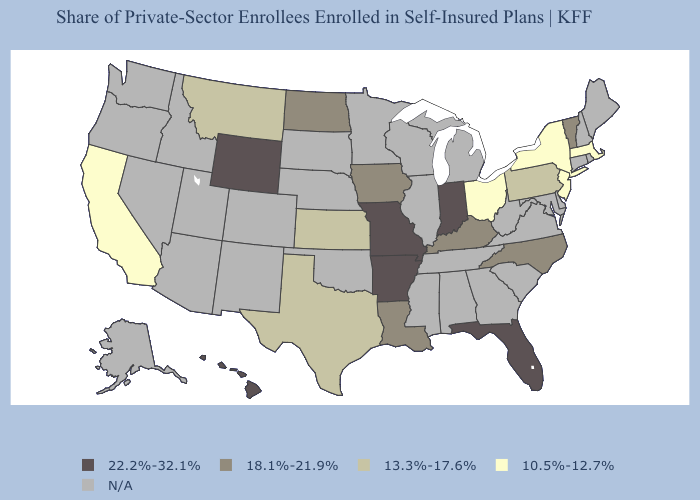What is the lowest value in the USA?
Concise answer only. 10.5%-12.7%. Name the states that have a value in the range N/A?
Quick response, please. Alabama, Alaska, Arizona, Colorado, Connecticut, Delaware, Georgia, Idaho, Illinois, Maine, Maryland, Michigan, Minnesota, Mississippi, Nebraska, Nevada, New Hampshire, New Mexico, Oklahoma, Oregon, Rhode Island, South Carolina, South Dakota, Tennessee, Utah, Virginia, Washington, West Virginia, Wisconsin. What is the value of Rhode Island?
Give a very brief answer. N/A. Name the states that have a value in the range 10.5%-12.7%?
Short answer required. California, Massachusetts, New Jersey, New York, Ohio. What is the value of Connecticut?
Keep it brief. N/A. Does the first symbol in the legend represent the smallest category?
Write a very short answer. No. Name the states that have a value in the range 18.1%-21.9%?
Write a very short answer. Iowa, Kentucky, Louisiana, North Carolina, North Dakota, Vermont. Does Massachusetts have the highest value in the USA?
Be succinct. No. Does Ohio have the lowest value in the MidWest?
Quick response, please. Yes. What is the value of Maine?
Answer briefly. N/A. Name the states that have a value in the range 22.2%-32.1%?
Give a very brief answer. Arkansas, Florida, Hawaii, Indiana, Missouri, Wyoming. What is the value of Georgia?
Short answer required. N/A. Does the first symbol in the legend represent the smallest category?
Concise answer only. No. 